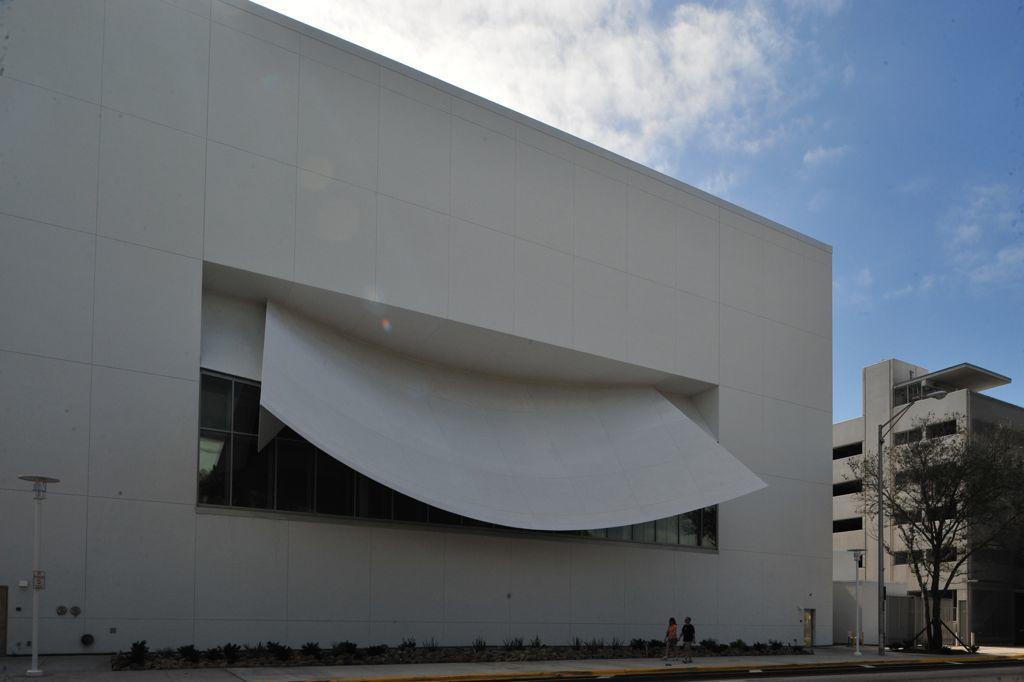Please provide a concise description of this image. In this image we can see the building, light pole, some white color poles, plants and also a tree on the right. We can also see two persons walking on the path. In the background we can see the sky with the clouds. 